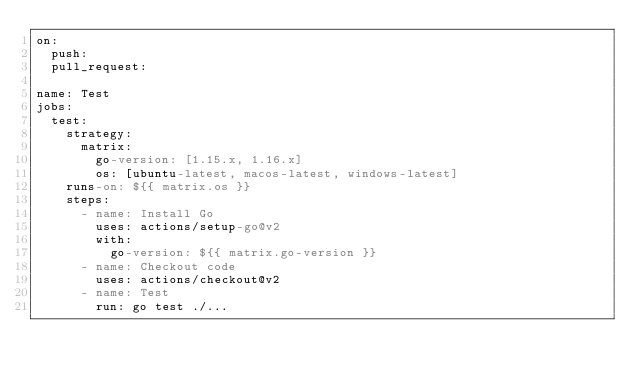<code> <loc_0><loc_0><loc_500><loc_500><_YAML_>on:
  push:
  pull_request:

name: Test
jobs:
  test:
    strategy:
      matrix:
        go-version: [1.15.x, 1.16.x]
        os: [ubuntu-latest, macos-latest, windows-latest]
    runs-on: ${{ matrix.os }}
    steps:
      - name: Install Go
        uses: actions/setup-go@v2
        with:
          go-version: ${{ matrix.go-version }}
      - name: Checkout code
        uses: actions/checkout@v2
      - name: Test
        run: go test ./...
</code> 